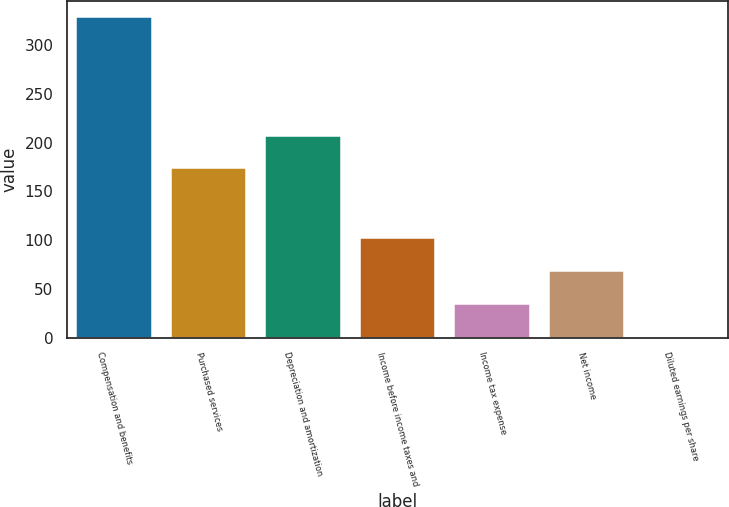<chart> <loc_0><loc_0><loc_500><loc_500><bar_chart><fcel>Compensation and benefits<fcel>Purchased services<fcel>Depreciation and amortization<fcel>Income before income taxes and<fcel>Income tax expense<fcel>Net income<fcel>Diluted earnings per share<nl><fcel>328.7<fcel>173.7<fcel>206.51<fcel>102.2<fcel>34.1<fcel>68.1<fcel>0.6<nl></chart> 